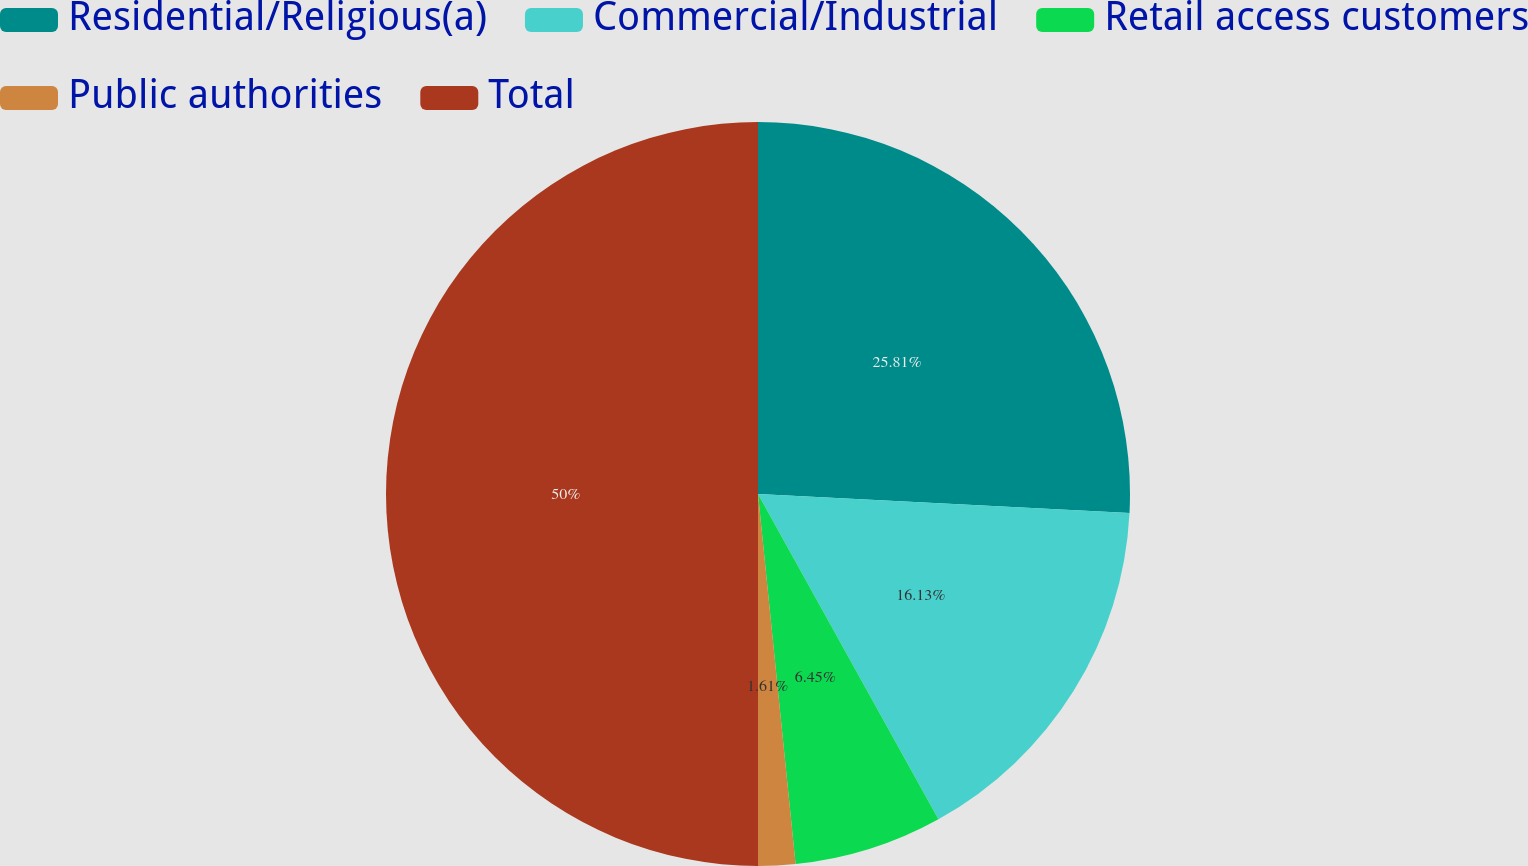Convert chart to OTSL. <chart><loc_0><loc_0><loc_500><loc_500><pie_chart><fcel>Residential/Religious(a)<fcel>Commercial/Industrial<fcel>Retail access customers<fcel>Public authorities<fcel>Total<nl><fcel>25.81%<fcel>16.13%<fcel>6.45%<fcel>1.61%<fcel>50.0%<nl></chart> 